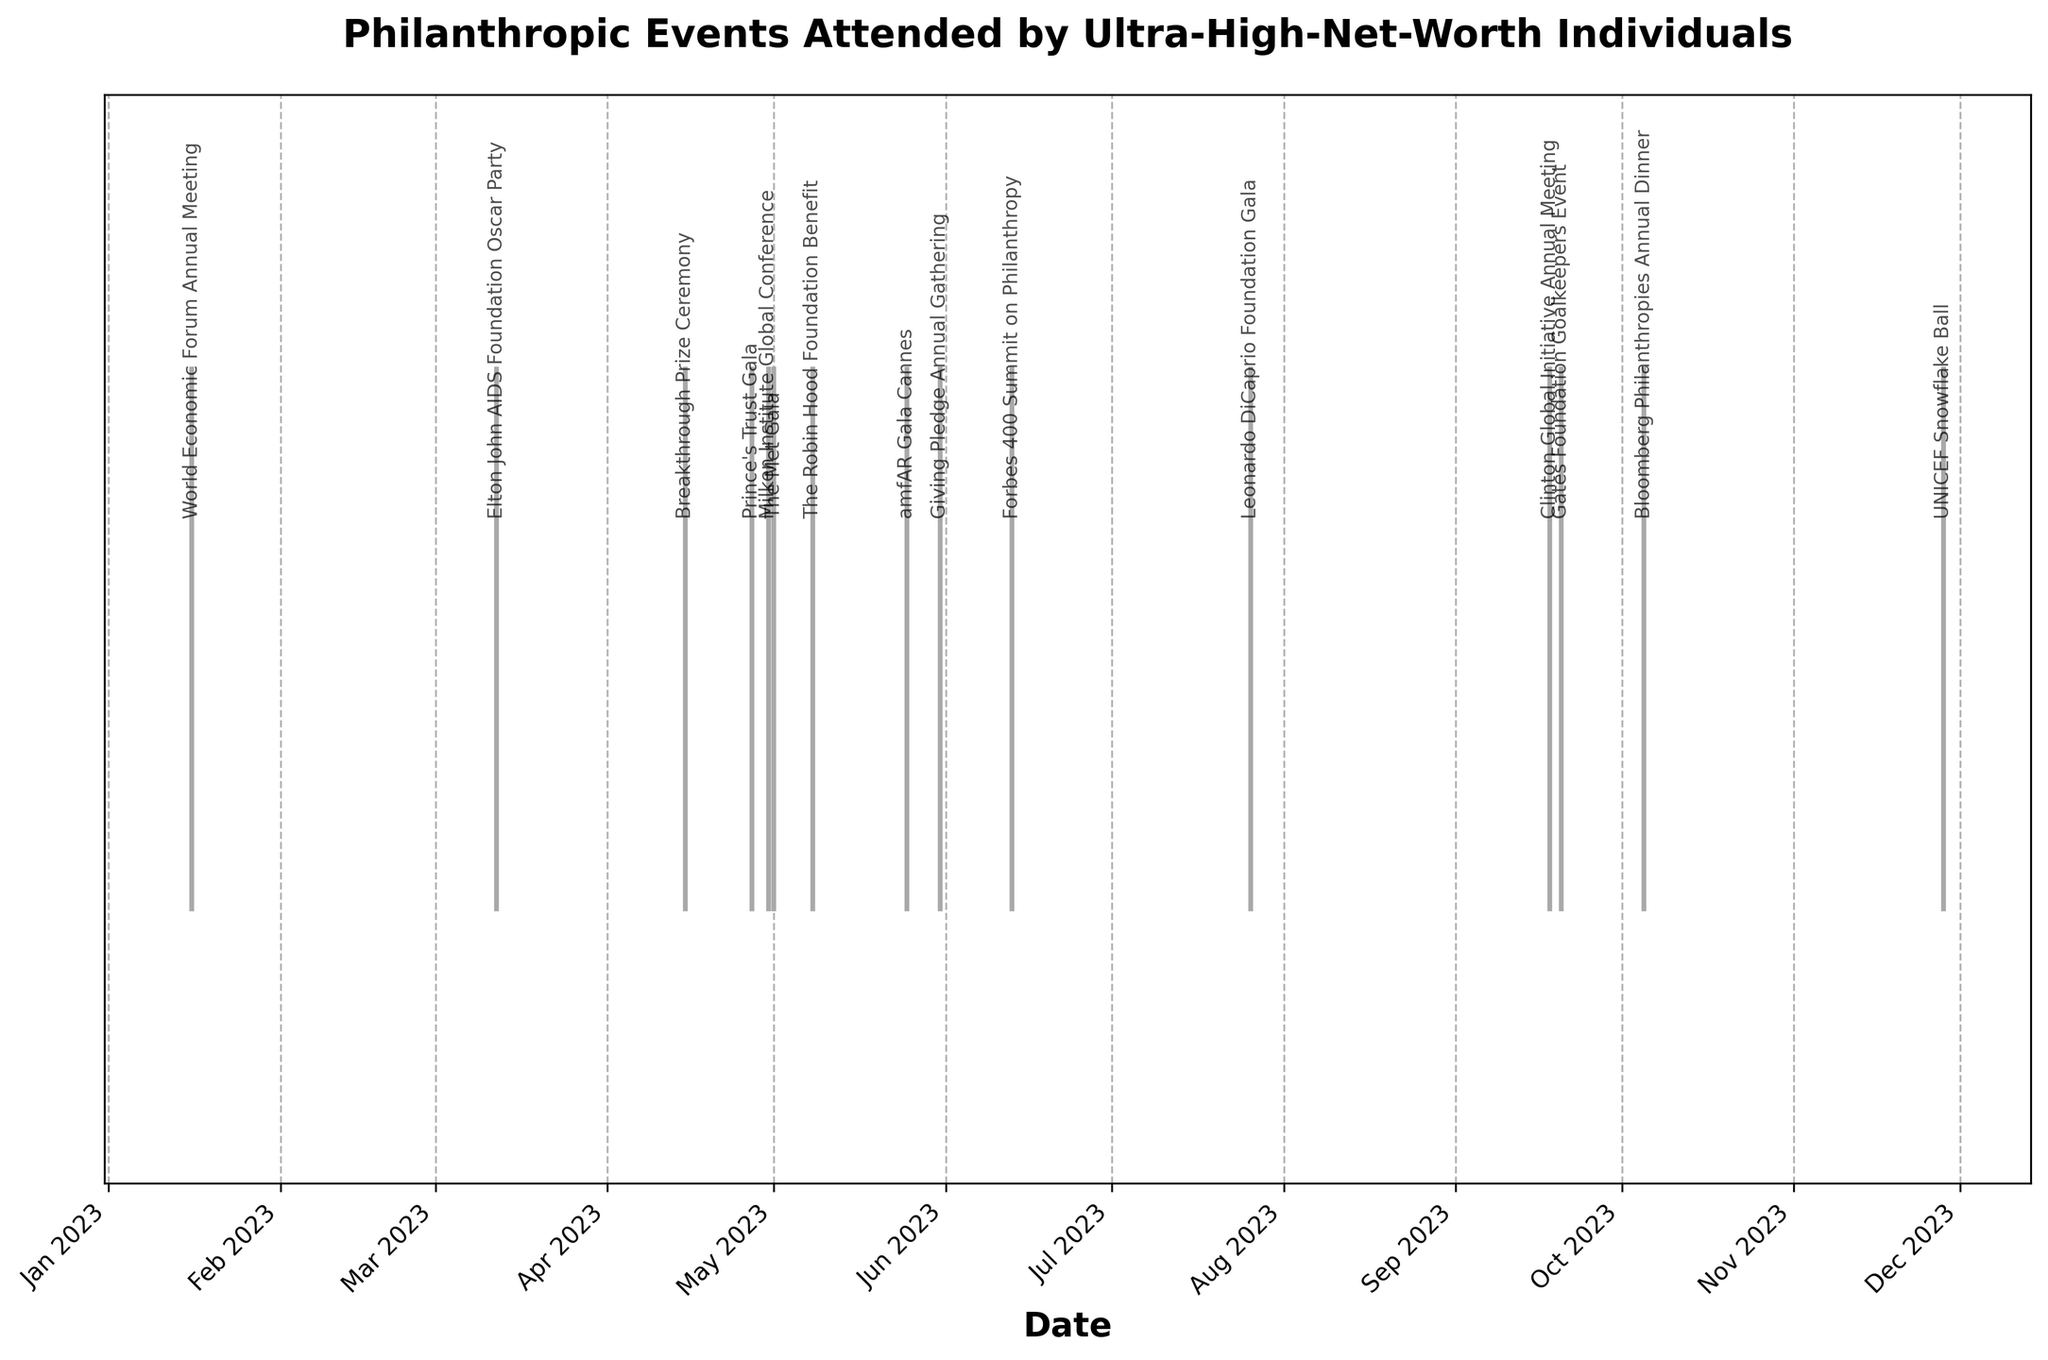What is the title of the plot? The title is usually prominently displayed at the top of the plot. Read the label at the top-center of the figure.
Answer: Philanthropic Events Attended by Ultra-High-Net-Worth Individuals On which date was the World Economic Forum Annual Meeting held? Look for the label "World Economic Forum Annual Meeting" along the x-axis and check the corresponding date below it.
Answer: January 16, 2023 How many philanthropic events took place in May 2023? Identify the events listed in May 2023 by examining the x-axis labels and count them.
Answer: 5 Which event took place the latest in the year? Look for the event label positioned furthest to the right along the x-axis, which represents the latest date.
Answer: UNICEF Snowflake Ball How many events occurred before June 2023? Determine the events that took place from January to May 2023 by visually counting them from the left to just before June 2023.
Answer: 8 Which is the earliest event in the year? Locate the event that appears first on the x-axis when sorted from left to right, as it represents the earliest date.
Answer: World Economic Forum Annual Meeting Which two events occurred closest to each other? Observe the spacing between event markers on the x-axis and identify the pair with the smallest gap between them.
Answer: Clinton Global Initiative Annual Meeting and Gates Foundation Goalkeepers Event What's the average time interval between events from April 2023 to July 2023? Calculate the time gaps between each consecutive event from April to July, sum them up, and divide by the number of gaps.
Answer: 8.25 days Which event took place right after the Bloomberg Philanthropies Annual Dinner? Check the x-axis and find the event label immediately following the Bloomberg Philanthropies Annual Dinner markers.
Answer: Clinton Global Initiative Annual Meeting How many events took place after July 2023? Count the number of events listed after July by examining the x-axis labels to the right of July 2023.
Answer: 4 